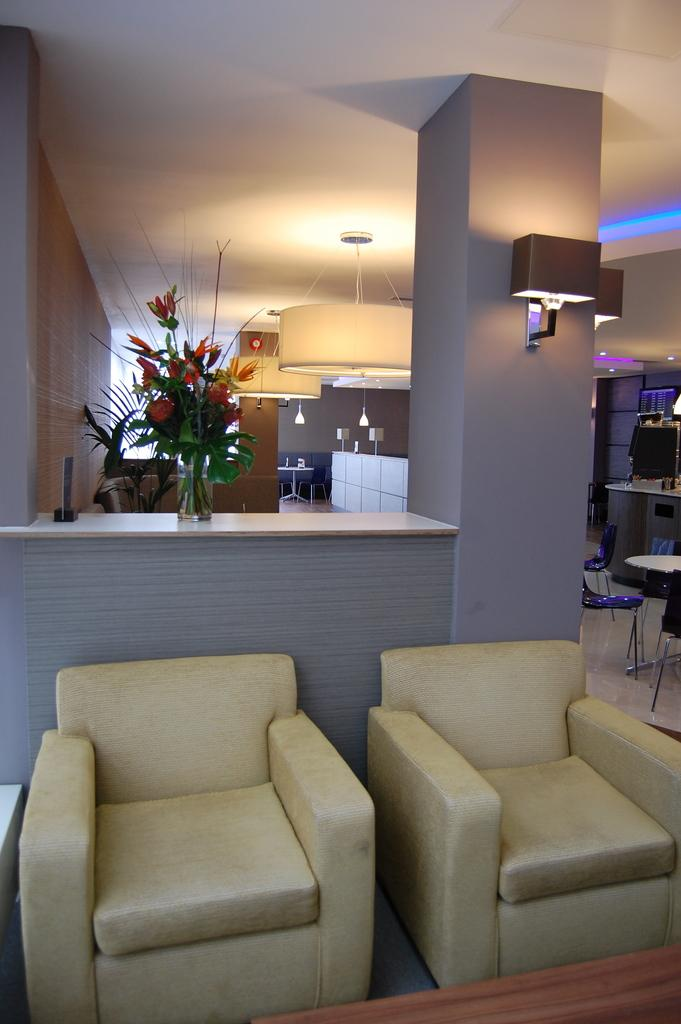What type of furniture is present in the image? There is a chair in the image. What architectural feature can be seen in the image? There is a pillar in the image. What is on top of the pillar? There is a pillar lamp on the pillar. What type of decoration is present in the image? There is a flower bouquet in a glass. What type of sticks are used to make the flower bouquet in the image? There are no sticks visible in the image, and the flower bouquet is in a glass. How many drops of water can be seen falling from the pillar lamp in the image? There is no indication of water droplets or any liquid in the image, so it is not possible to determine the number of drops. 